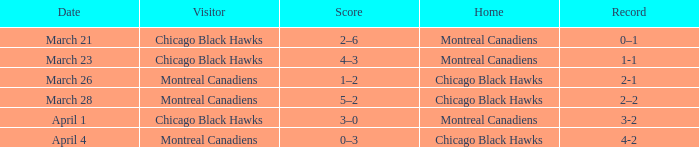Can you give me this table as a dict? {'header': ['Date', 'Visitor', 'Score', 'Home', 'Record'], 'rows': [['March 21', 'Chicago Black Hawks', '2–6', 'Montreal Canadiens', '0–1'], ['March 23', 'Chicago Black Hawks', '4–3', 'Montreal Canadiens', '1-1'], ['March 26', 'Montreal Canadiens', '1–2', 'Chicago Black Hawks', '2-1'], ['March 28', 'Montreal Canadiens', '5–2', 'Chicago Black Hawks', '2–2'], ['April 1', 'Chicago Black Hawks', '3–0', 'Montreal Canadiens', '3-2'], ['April 4', 'Montreal Canadiens', '0–3', 'Chicago Black Hawks', '4-2']]} What is the team's score with a 2-1 performance? 1–2. 